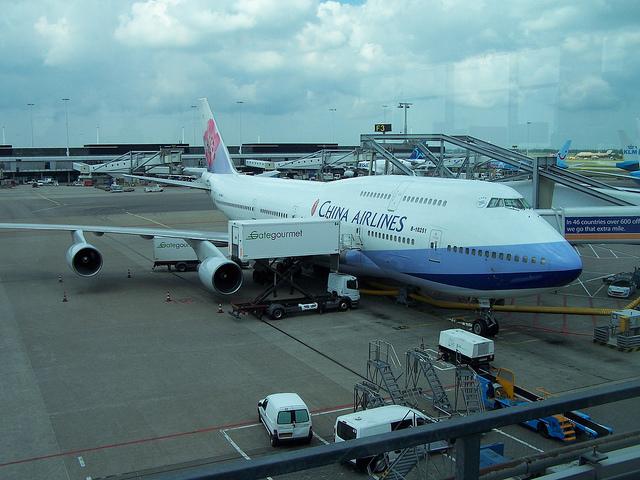What type of place is this?
Write a very short answer. Airport. What airline is represented?
Short answer required. China airlines. What letters are on the green and brown plane?
Quick response, please. China airlines. Is the truck pulling the plane?
Short answer required. No. Is the sky overcast?
Short answer required. Yes. What is on the runway?
Keep it brief. Plane. 